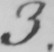Please provide the text content of this handwritten line. 3 . 